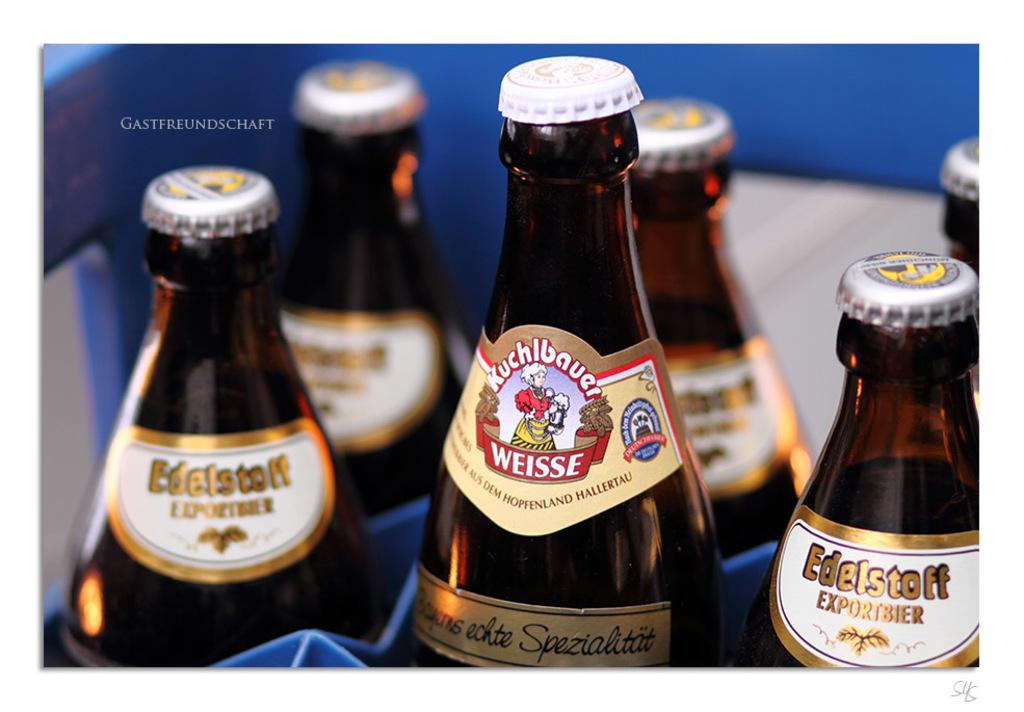<image>
Describe the image concisely. The tops of several bottles of Kuchbauer and Edelstoff 